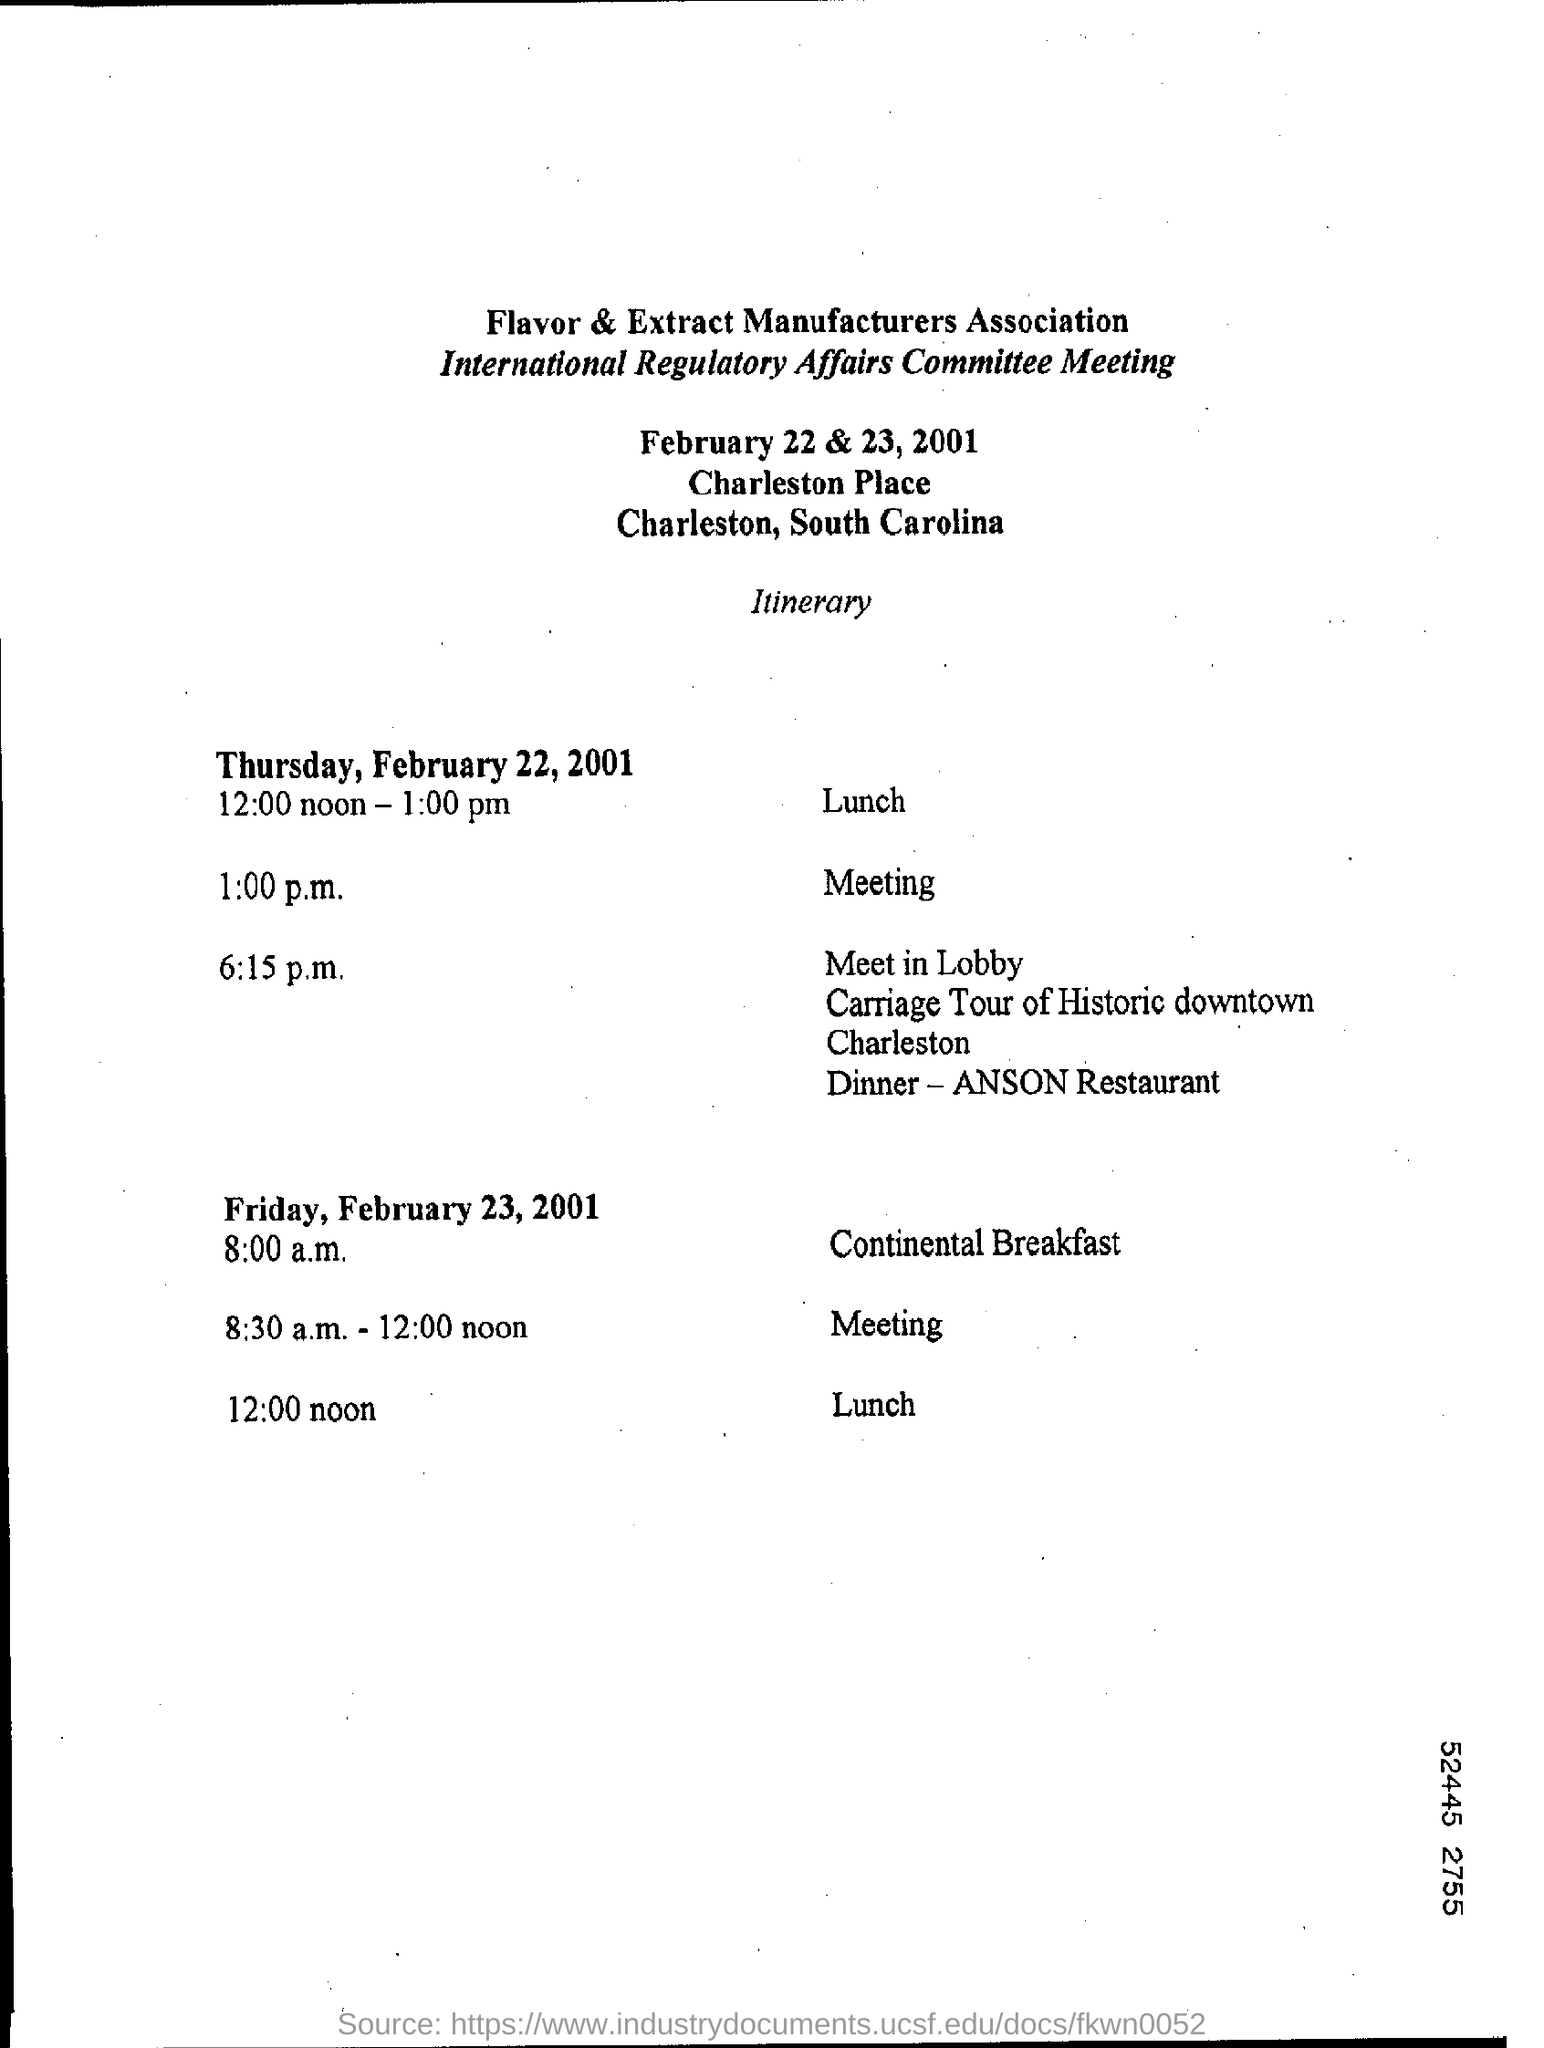What time is Meeting for Thursday, February 22, 2001?
Your answer should be very brief. 1:00 p.m. What time is Lunch for Thursday, February 22, 2001?
Your answer should be compact. 12:00 noon - 1:00 pm. What time is Meeting for Friday, February 23, 2001?
Your answer should be very brief. 8:30 a.m. - 12:00 noon. What time is Lunch for Friday, February 23, 2001?
Provide a succinct answer. 12:00 noon. What time is Continental Breakfast for Friday, February 23, 2001?
Your answer should be compact. 8:00 a.m. 